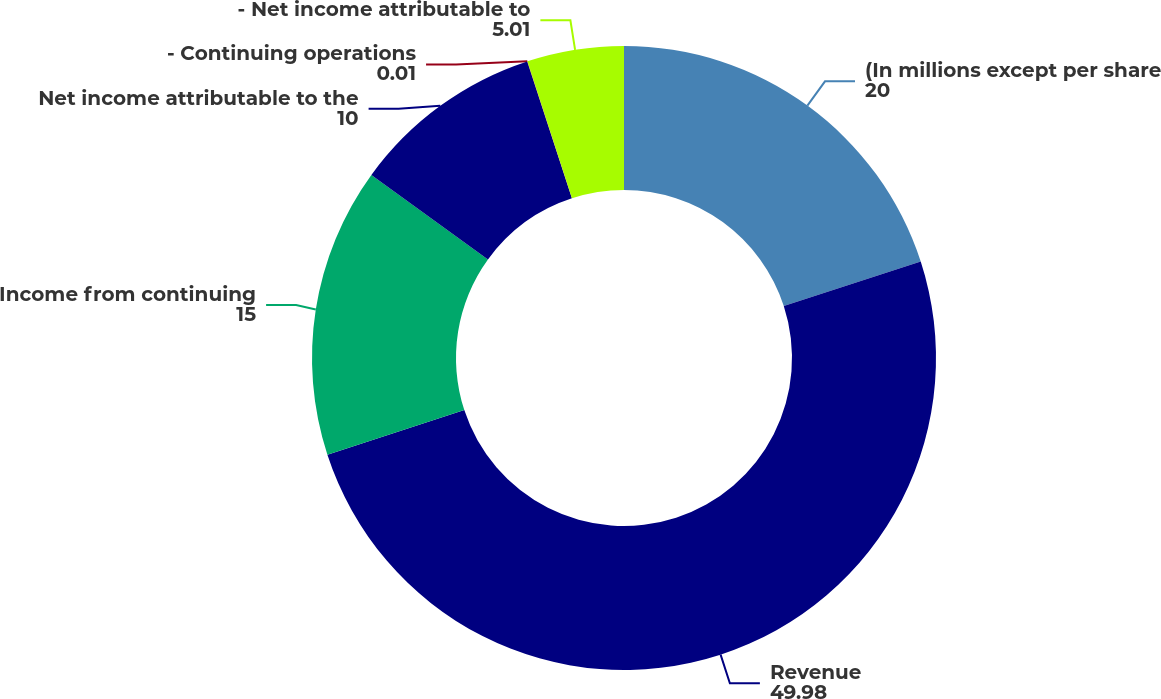Convert chart. <chart><loc_0><loc_0><loc_500><loc_500><pie_chart><fcel>(In millions except per share<fcel>Revenue<fcel>Income from continuing<fcel>Net income attributable to the<fcel>- Continuing operations<fcel>- Net income attributable to<nl><fcel>20.0%<fcel>49.98%<fcel>15.0%<fcel>10.0%<fcel>0.01%<fcel>5.01%<nl></chart> 